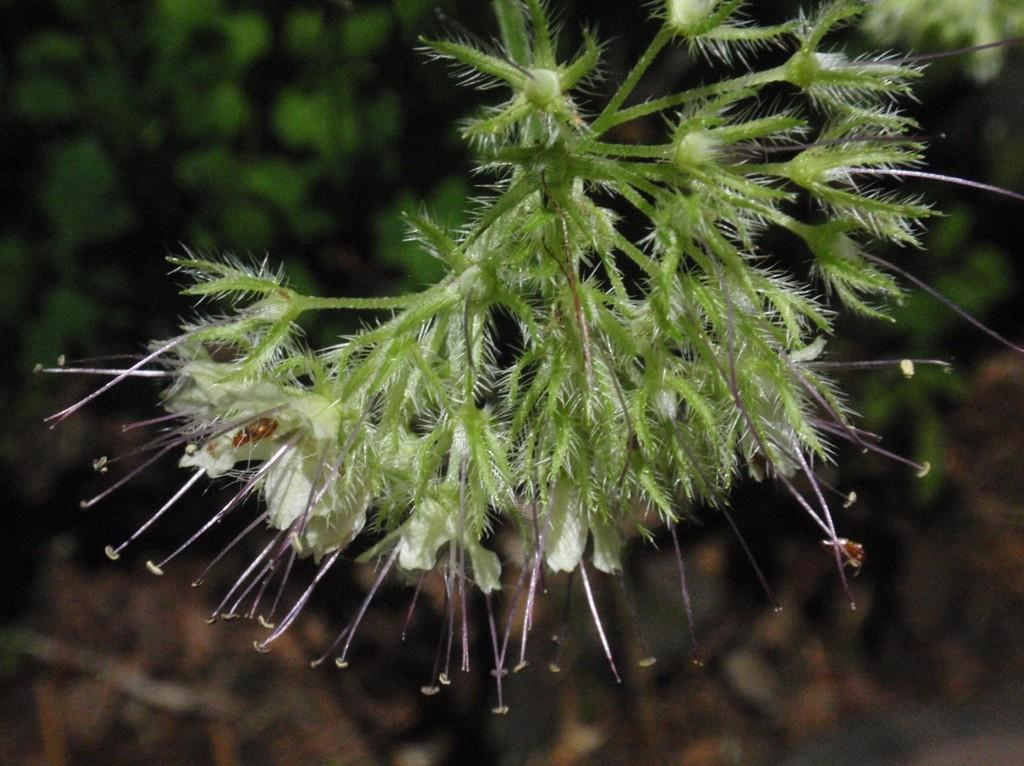What is present in the image? There is a plant in the image. What type of flowers does the plant have? The plant has white flowers. Can you describe the background of the image? The background of the image is blurred. Can you tell me how many circles are visible in the image? There is no circle present in the image. What type of example can be seen in the image? There is no example present in the image; it features a plant with white flowers against a blurred background. 